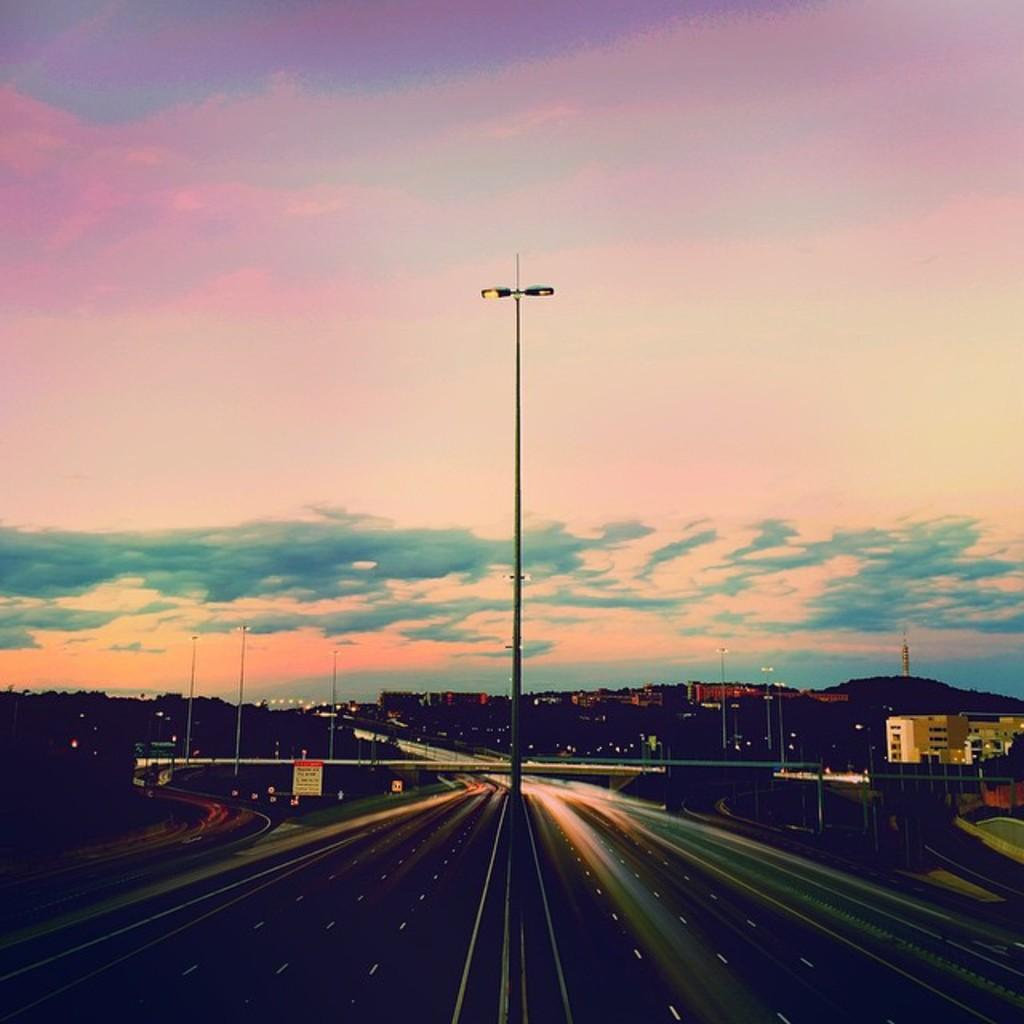What is the main subject of the image? The main subject of the image is a view of a road. Where is the road located in the image? The road is in the front bottom side of the image. What else can be seen in the image besides the road? There is a street pole, buildings, and the sky visible in the image. What is the condition of the sky in the image? The sky is visible in the image, and clouds are present. Can you tell me how many times the yoke is used on the road in the image? There is no yoke present in the image, so it cannot be determined how many times it is used. 